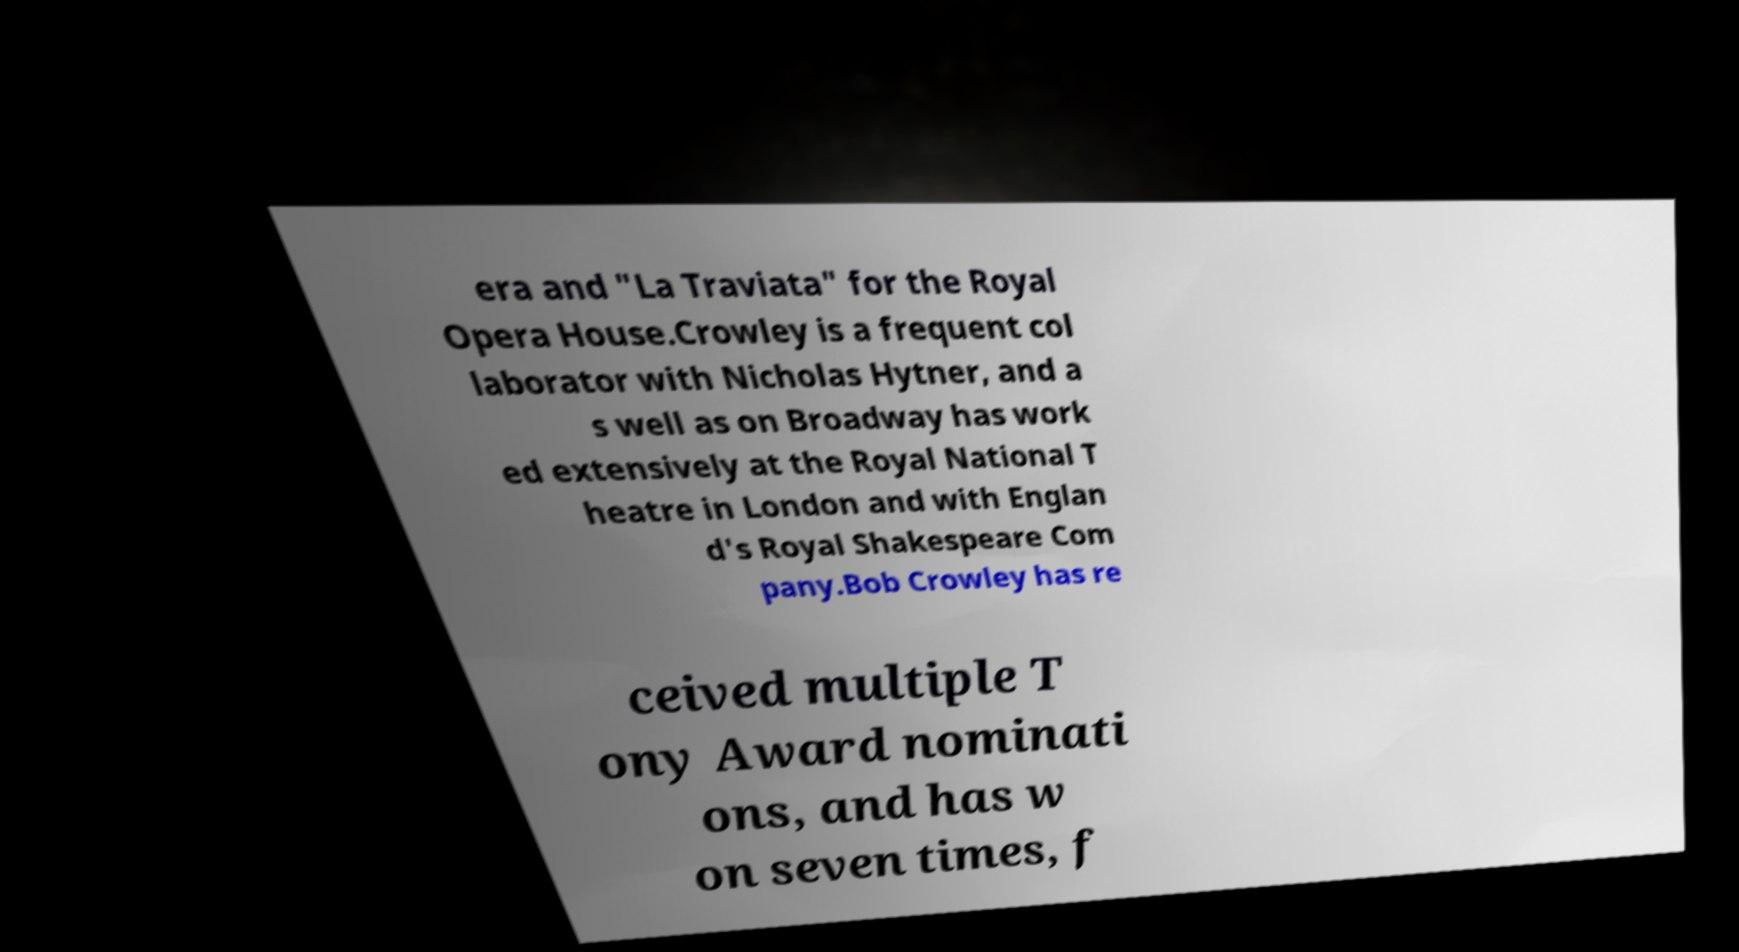What messages or text are displayed in this image? I need them in a readable, typed format. era and "La Traviata" for the Royal Opera House.Crowley is a frequent col laborator with Nicholas Hytner, and a s well as on Broadway has work ed extensively at the Royal National T heatre in London and with Englan d's Royal Shakespeare Com pany.Bob Crowley has re ceived multiple T ony Award nominati ons, and has w on seven times, f 